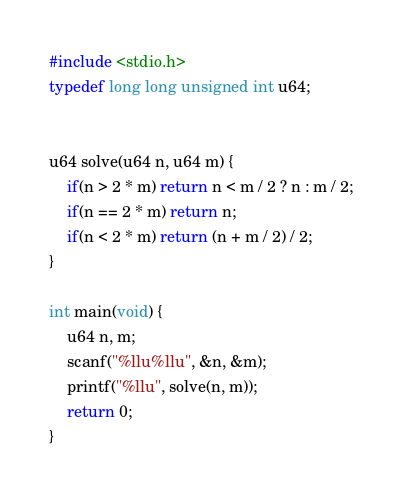<code> <loc_0><loc_0><loc_500><loc_500><_C_>#include <stdio.h>
typedef long long unsigned int u64;


u64 solve(u64 n, u64 m) {
    if(n > 2 * m) return n < m / 2 ? n : m / 2;
    if(n == 2 * m) return n;
    if(n < 2 * m) return (n + m / 2) / 2;
}

int main(void) {
    u64 n, m;
    scanf("%llu%llu", &n, &m);
    printf("%llu", solve(n, m));
    return 0;
}</code> 